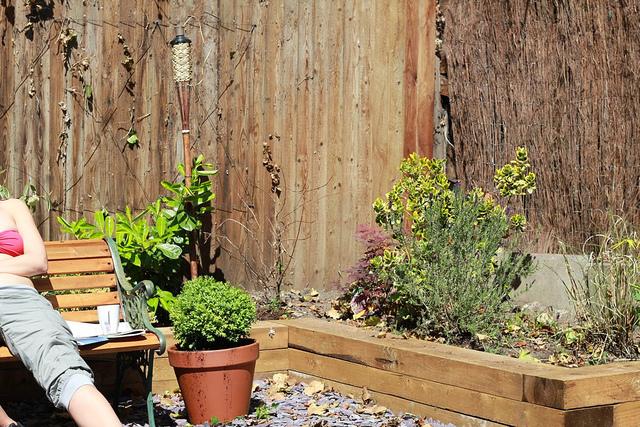Are the plants trying to escape?
Answer briefly. No. Where are the pieces of wood?
Give a very brief answer. On ground. What in the person doing?
Be succinct. Sitting. What color are the plants?
Concise answer only. Green. Are some of the plants in bloom?
Give a very brief answer. Yes. What color plant is in the clay pot?
Short answer required. Green. 